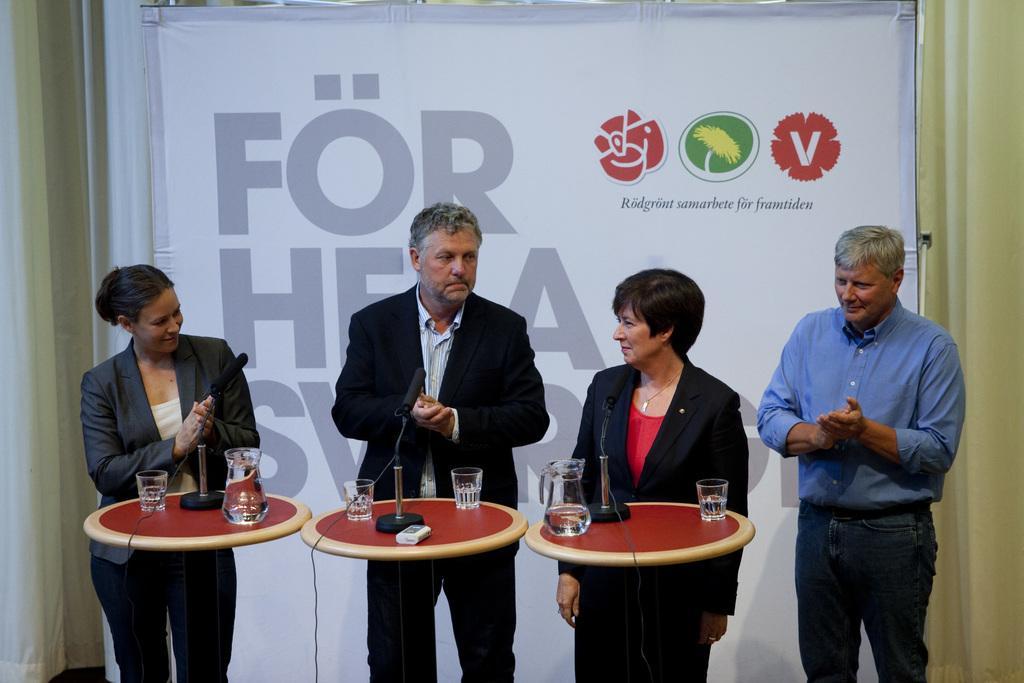Could you give a brief overview of what you see in this image? In this picture there are four people Standing and there is a banner behind them in front of them there is a table with water glass water jar and a microphone 